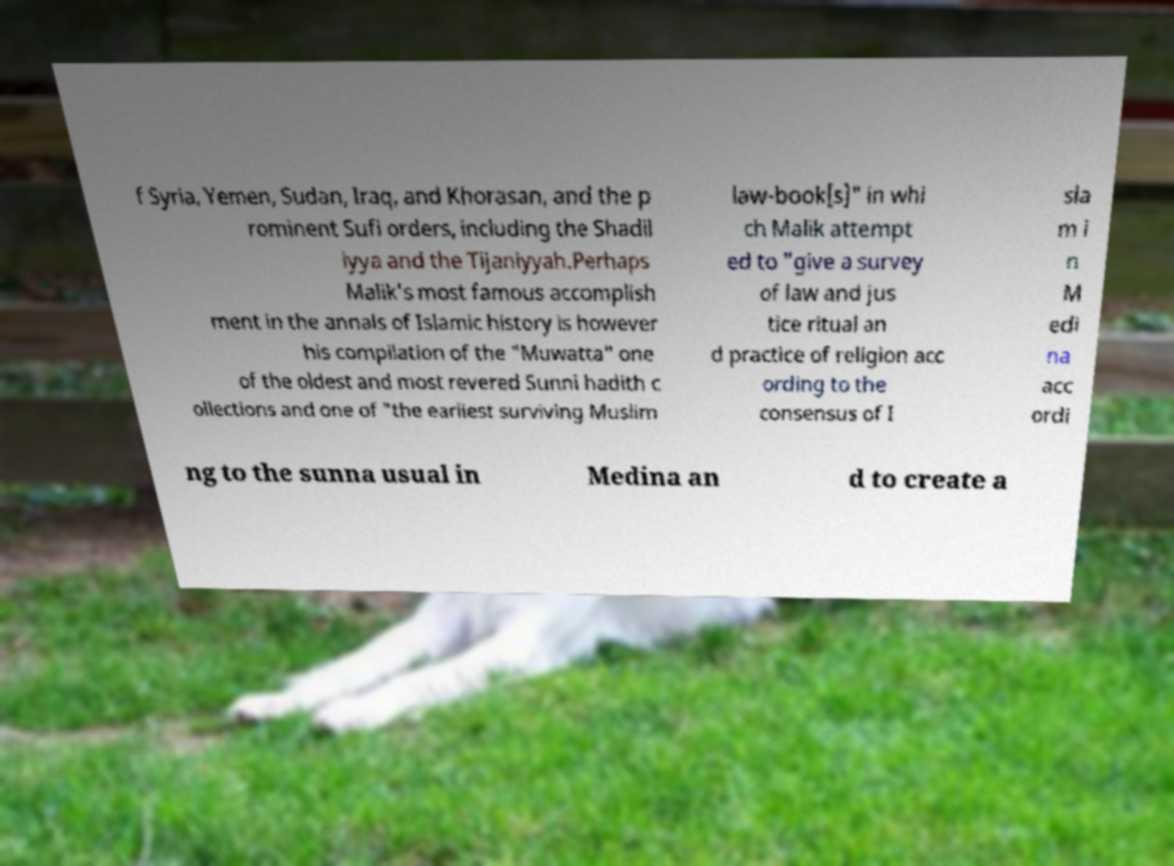Please identify and transcribe the text found in this image. f Syria, Yemen, Sudan, Iraq, and Khorasan, and the p rominent Sufi orders, including the Shadil iyya and the Tijaniyyah.Perhaps Malik's most famous accomplish ment in the annals of Islamic history is however his compilation of the "Muwatta" one of the oldest and most revered Sunni hadith c ollections and one of "the earliest surviving Muslim law-book[s]" in whi ch Malik attempt ed to "give a survey of law and jus tice ritual an d practice of religion acc ording to the consensus of I sla m i n M edi na acc ordi ng to the sunna usual in Medina an d to create a 